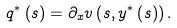<formula> <loc_0><loc_0><loc_500><loc_500>q ^ { \ast } \left ( s \right ) = \partial _ { x } v \left ( s , y ^ { \ast } \left ( s \right ) \right ) .</formula> 